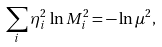Convert formula to latex. <formula><loc_0><loc_0><loc_500><loc_500>\sum _ { i } \eta _ { i } ^ { 2 } \, \ln M _ { i } ^ { 2 } = - \ln \mu ^ { 2 } ,</formula> 